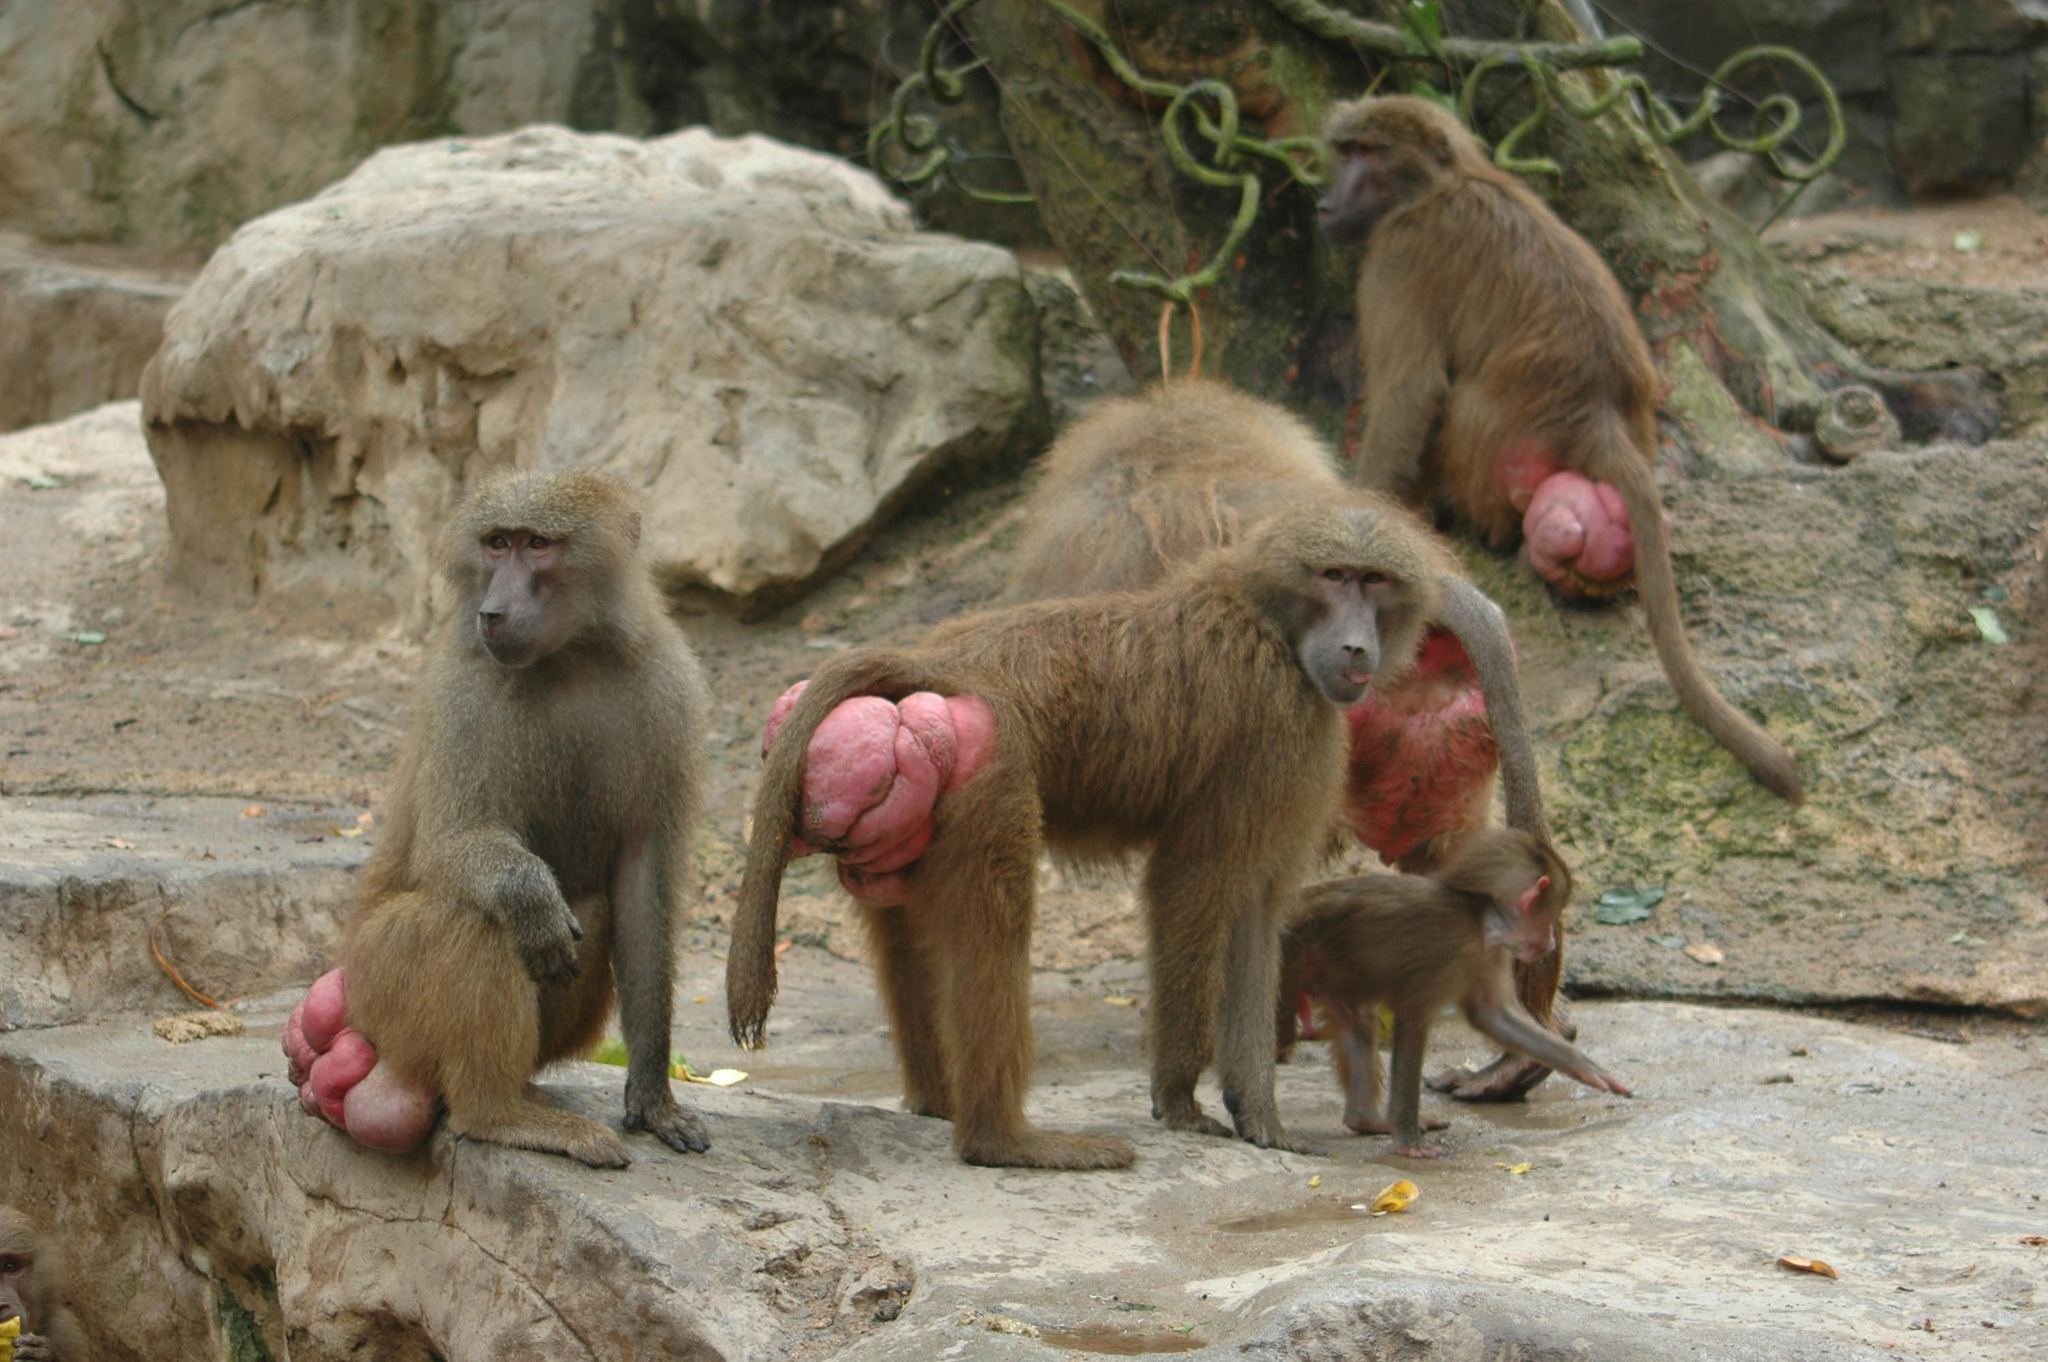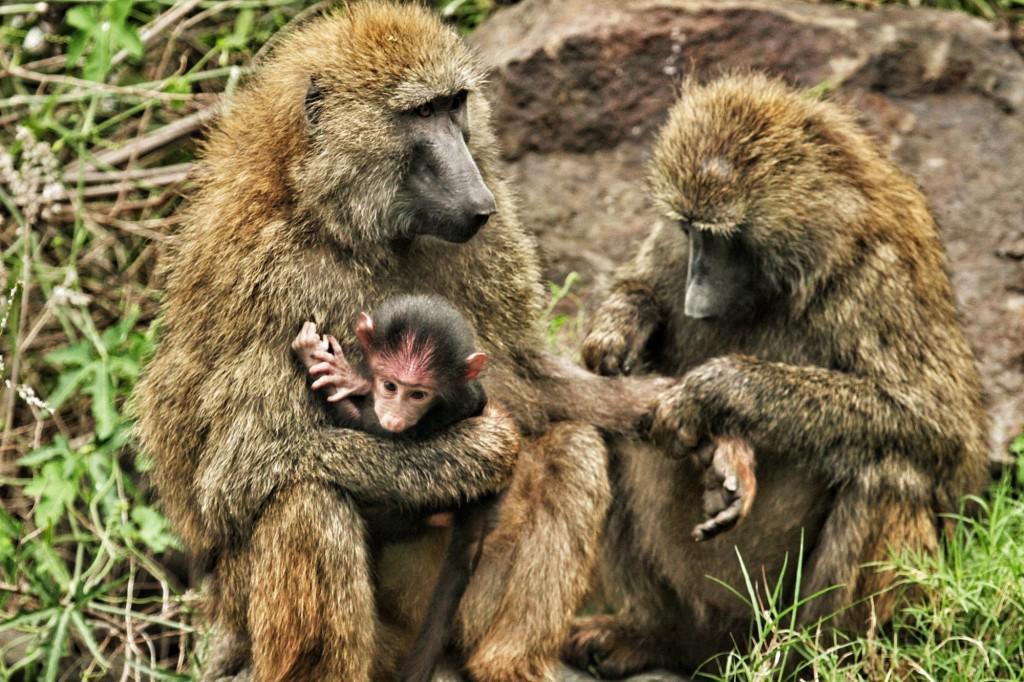The first image is the image on the left, the second image is the image on the right. For the images displayed, is the sentence "There's at least one monkey eating an animal." factually correct? Answer yes or no. No. 